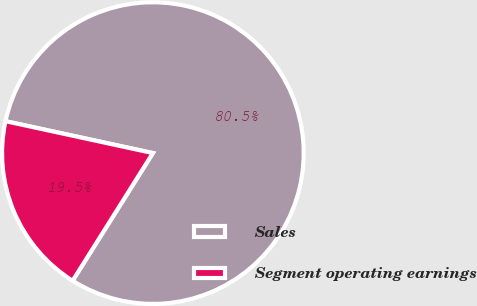Convert chart. <chart><loc_0><loc_0><loc_500><loc_500><pie_chart><fcel>Sales<fcel>Segment operating earnings<nl><fcel>80.54%<fcel>19.46%<nl></chart> 